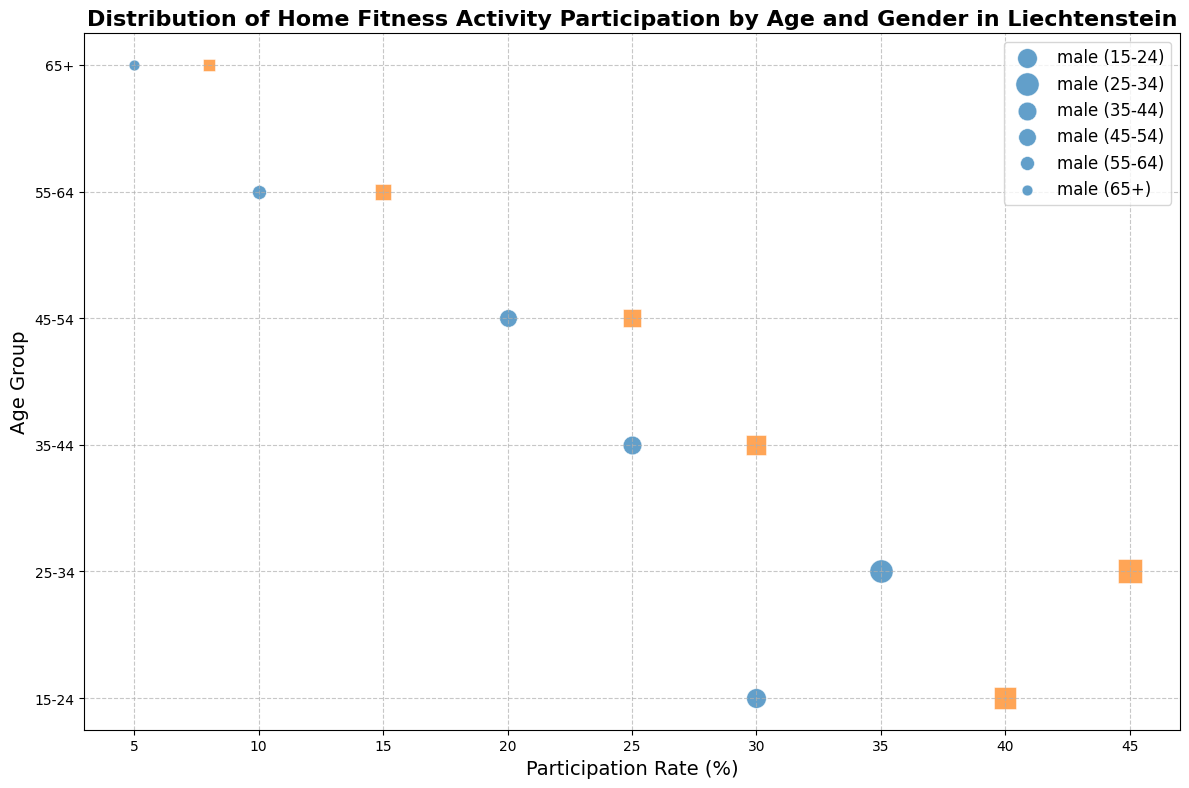How does the participation rate of 25-34-year-old women compare to that of 25-34-year-old men? The participation rate of 25-34-year-old women is represented by the orange square at 45%, while the 25-34-year-old men are represented by the blue circle at 35%. Comparing these shows women participate more than men in this age group.
Answer: Women participate 10% more than men Which age group of males has the lowest participation rate? Looking at the blue circles representing males, the smallest circle appears in the 65+ age group at 5%.
Answer: 65+ age group What is the average participation rate for the 45-54 age group? The female participation rate is 25% and the male rate is 20%. Summing these and dividing by 2 gives the average: (25 + 20)/2 = 22.5%.
Answer: 22.5% Among all age groups, which gender has the higher participation rate? By examining the bubbles, females consistently have higher participation rates across all age groups compared to males.
Answer: Female What is the total size representation for the 55-64 age group? The sizes are 5 for males and 6 for females, adding these gives a total size of 11.
Answer: 11 In which age group do we see the largest difference in participation rates between genders? For the 15-24 age group, females have a participation rate of 40% and males have 30%, making the difference 10%. Comparing other age groups confirms this is the largest difference.
Answer: 15-24 age group What does the size of the bubble represent in this chart? The size of the bubble represents the 'size' value from the data, which is scaled for better visibility. It reflects some measure of participation or population, but exact meaning needs the data context.
Answer: Participation/population measure Is there any age group where the male participation rate is higher than the female participation rate? Scanning the chart, in all age groups, the blue circles (indicating male) are not positioned to the right of the orange squares (indicating female).
Answer: No What is the participation rate for 35-44-year-old females? The orange square in the 35-44 age group is at 30%.
Answer: 30% How does the participation rate for 65+ women compare with 55-64 men? The orange square for 65+ women indicates 8% while the blue circle for 55-64 men indicates 10%. Therefore, 55-64 men have a higher participation rate.
Answer: 55-64 men have a higher rate by 2% 